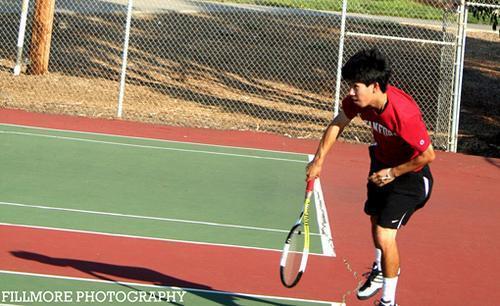How many people are in the photograph?
Give a very brief answer. 1. 